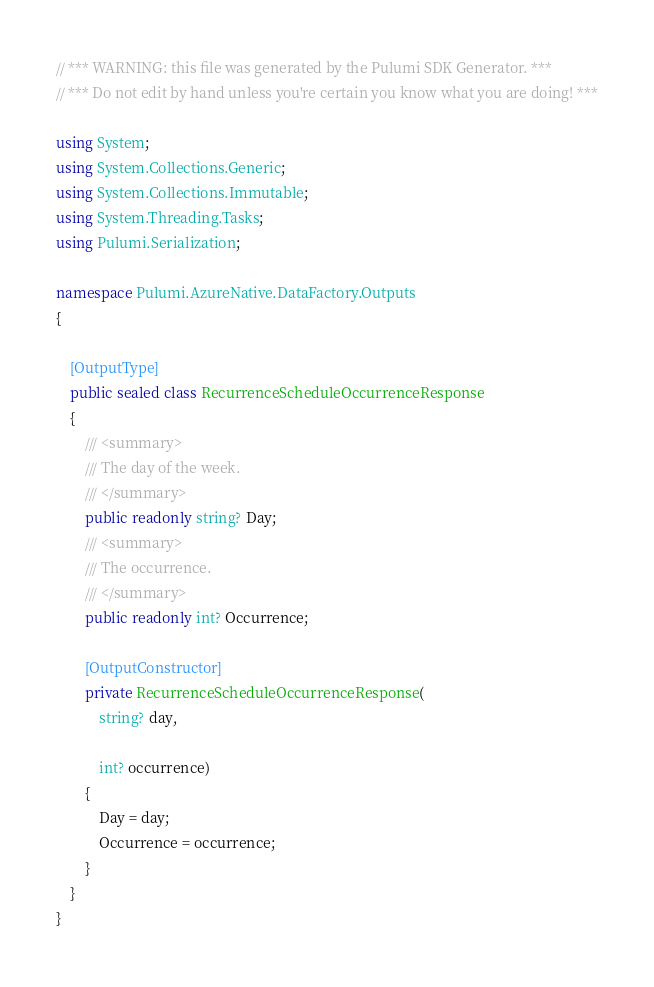<code> <loc_0><loc_0><loc_500><loc_500><_C#_>// *** WARNING: this file was generated by the Pulumi SDK Generator. ***
// *** Do not edit by hand unless you're certain you know what you are doing! ***

using System;
using System.Collections.Generic;
using System.Collections.Immutable;
using System.Threading.Tasks;
using Pulumi.Serialization;

namespace Pulumi.AzureNative.DataFactory.Outputs
{

    [OutputType]
    public sealed class RecurrenceScheduleOccurrenceResponse
    {
        /// <summary>
        /// The day of the week.
        /// </summary>
        public readonly string? Day;
        /// <summary>
        /// The occurrence.
        /// </summary>
        public readonly int? Occurrence;

        [OutputConstructor]
        private RecurrenceScheduleOccurrenceResponse(
            string? day,

            int? occurrence)
        {
            Day = day;
            Occurrence = occurrence;
        }
    }
}
</code> 